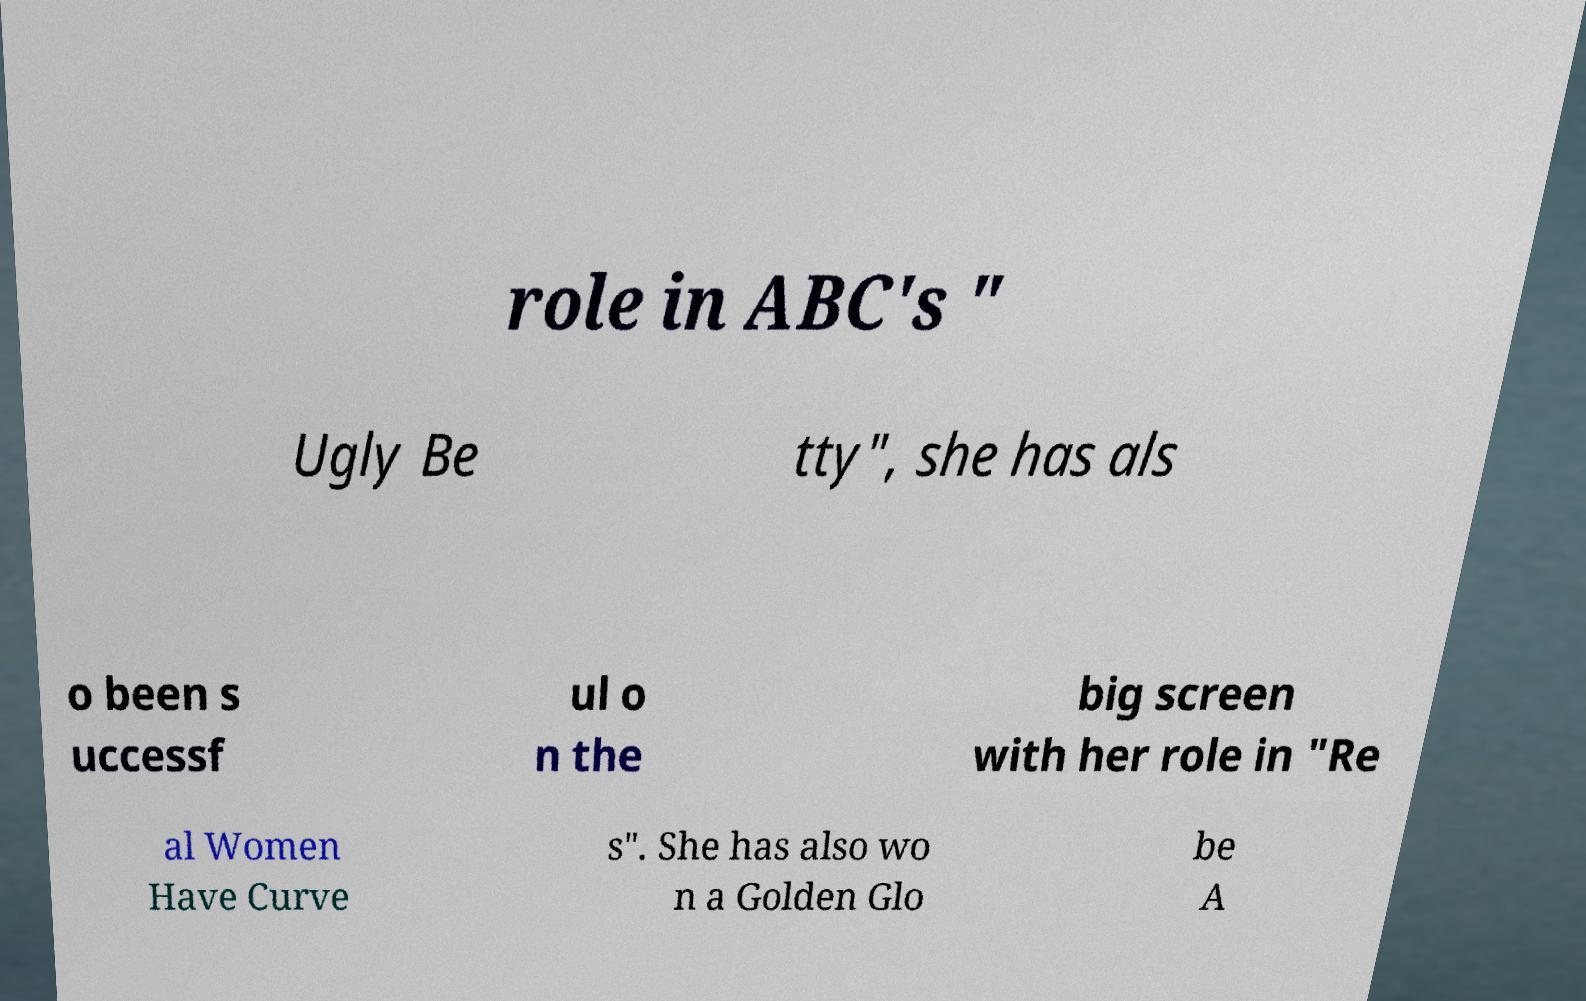Please identify and transcribe the text found in this image. role in ABC's " Ugly Be tty", she has als o been s uccessf ul o n the big screen with her role in "Re al Women Have Curve s". She has also wo n a Golden Glo be A 